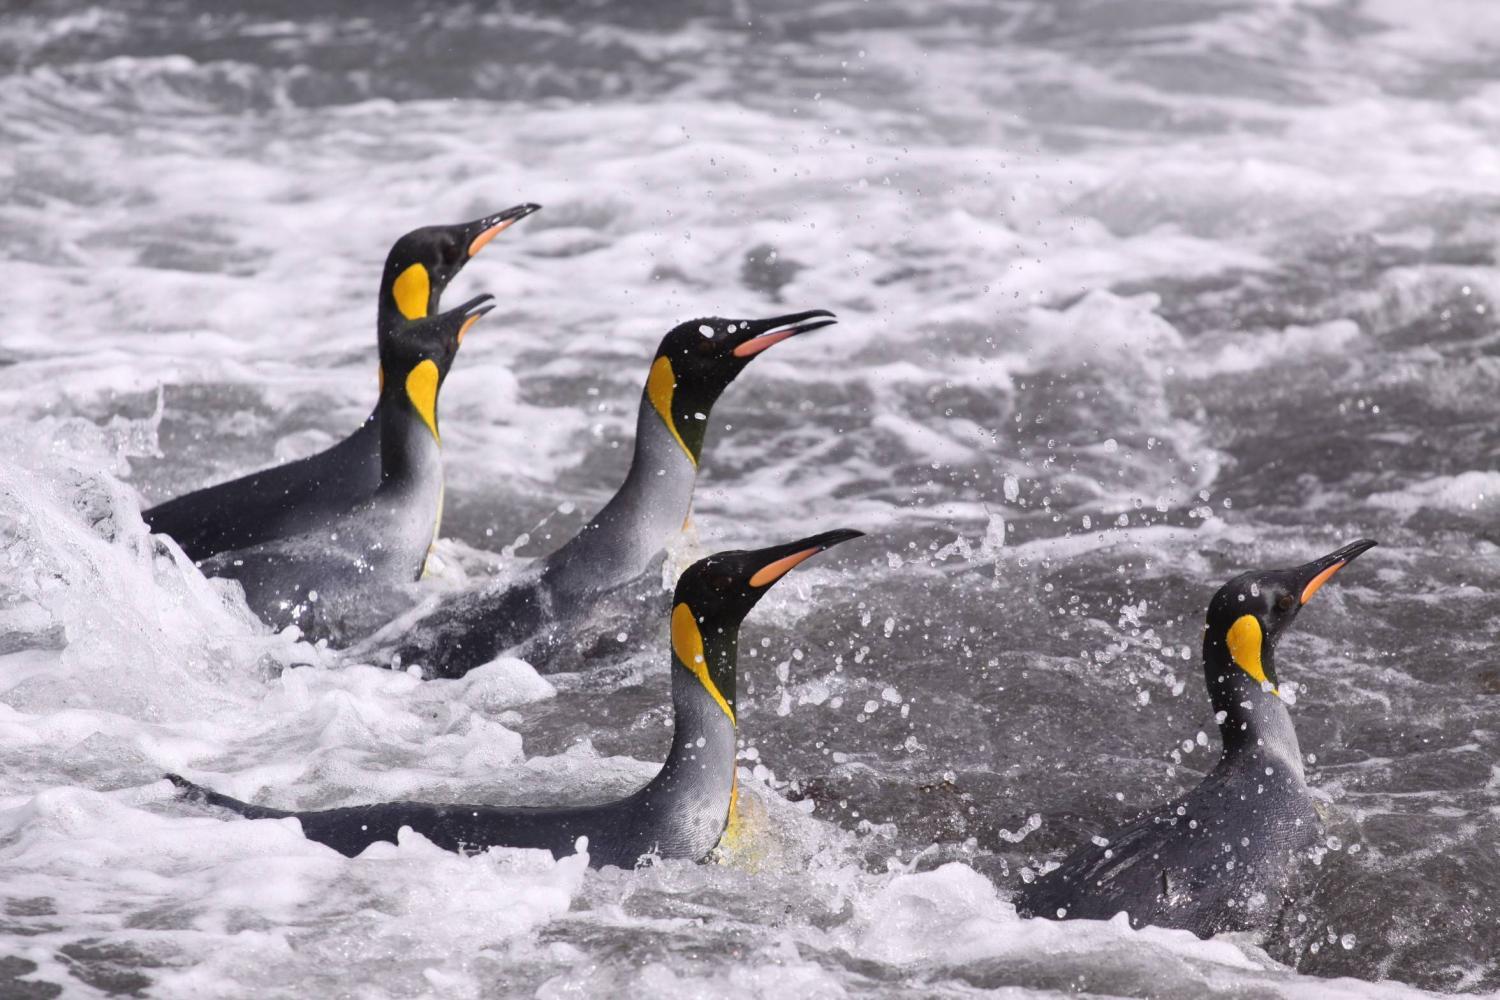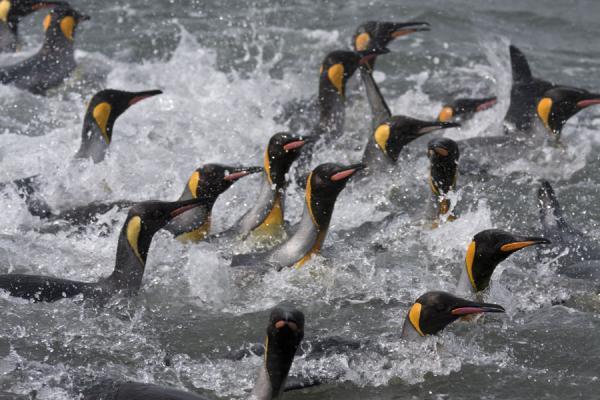The first image is the image on the left, the second image is the image on the right. Considering the images on both sides, is "There are no more than 2 penguins in one of the images." valid? Answer yes or no. No. The first image is the image on the left, the second image is the image on the right. Assess this claim about the two images: "An image shows multiple penguins swimming underwater where no ocean bottom is visible.". Correct or not? Answer yes or no. No. 